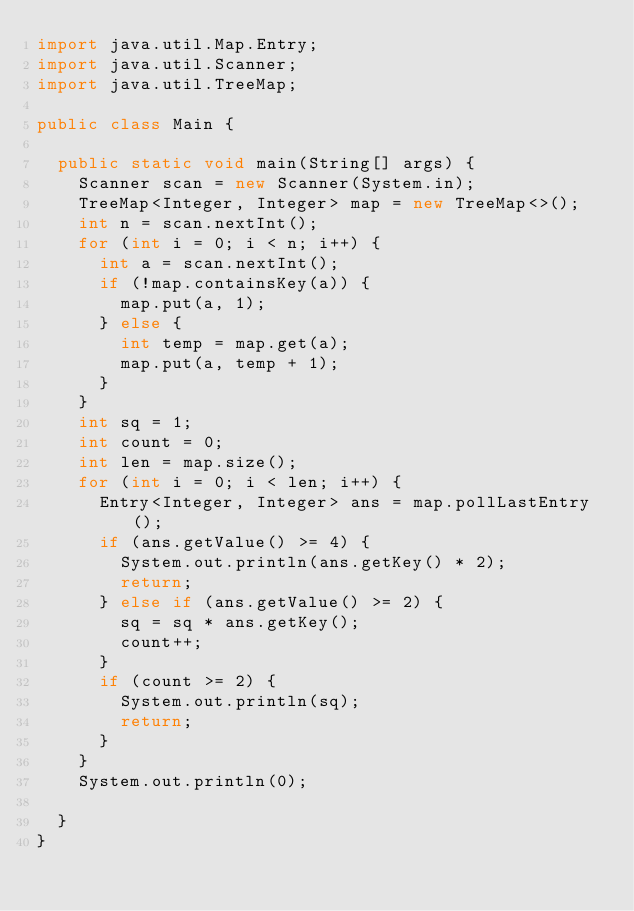<code> <loc_0><loc_0><loc_500><loc_500><_Java_>import java.util.Map.Entry;
import java.util.Scanner;
import java.util.TreeMap;

public class Main {

	public static void main(String[] args) {
		Scanner scan = new Scanner(System.in);
		TreeMap<Integer, Integer> map = new TreeMap<>();
		int n = scan.nextInt();
		for (int i = 0; i < n; i++) {
			int a = scan.nextInt();
			if (!map.containsKey(a)) {
				map.put(a, 1);
			} else {
				int temp = map.get(a);
				map.put(a, temp + 1);
			}
		}
		int sq = 1;
		int count = 0;
		int len = map.size();
		for (int i = 0; i < len; i++) {
			Entry<Integer, Integer> ans = map.pollLastEntry();
			if (ans.getValue() >= 4) {
				System.out.println(ans.getKey() * 2);
				return;
			} else if (ans.getValue() >= 2) {
				sq = sq * ans.getKey();
				count++;
			}
			if (count >= 2) {
				System.out.println(sq);
				return;
			}
		}
		System.out.println(0);

	}
}</code> 